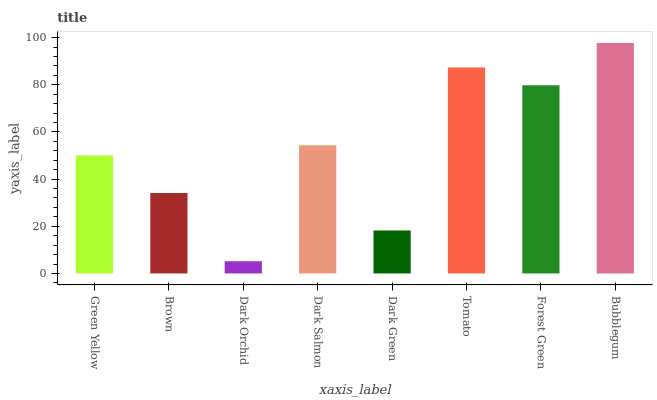Is Dark Orchid the minimum?
Answer yes or no. Yes. Is Bubblegum the maximum?
Answer yes or no. Yes. Is Brown the minimum?
Answer yes or no. No. Is Brown the maximum?
Answer yes or no. No. Is Green Yellow greater than Brown?
Answer yes or no. Yes. Is Brown less than Green Yellow?
Answer yes or no. Yes. Is Brown greater than Green Yellow?
Answer yes or no. No. Is Green Yellow less than Brown?
Answer yes or no. No. Is Dark Salmon the high median?
Answer yes or no. Yes. Is Green Yellow the low median?
Answer yes or no. Yes. Is Green Yellow the high median?
Answer yes or no. No. Is Tomato the low median?
Answer yes or no. No. 